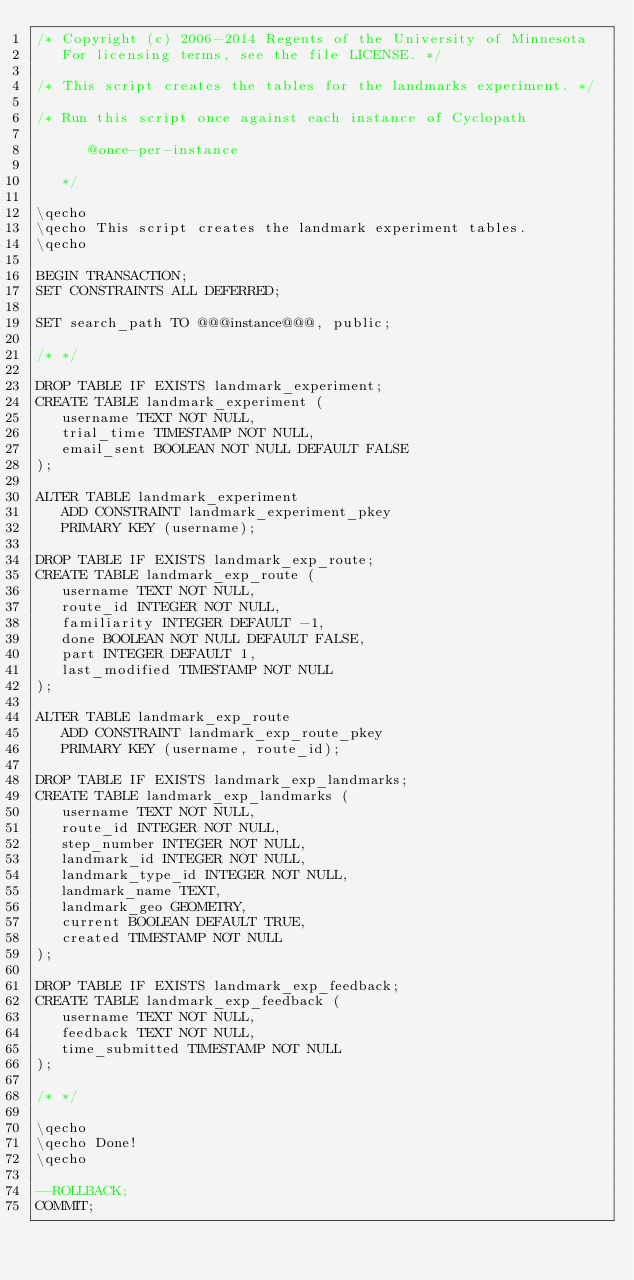<code> <loc_0><loc_0><loc_500><loc_500><_SQL_>/* Copyright (c) 2006-2014 Regents of the University of Minnesota
   For licensing terms, see the file LICENSE. */

/* This script creates the tables for the landmarks experiment. */

/* Run this script once against each instance of Cyclopath

      @once-per-instance

   */

\qecho
\qecho This script creates the landmark experiment tables.
\qecho

BEGIN TRANSACTION;
SET CONSTRAINTS ALL DEFERRED;

SET search_path TO @@@instance@@@, public;

/* */

DROP TABLE IF EXISTS landmark_experiment;
CREATE TABLE landmark_experiment (
   username TEXT NOT NULL,
   trial_time TIMESTAMP NOT NULL,
   email_sent BOOLEAN NOT NULL DEFAULT FALSE
);

ALTER TABLE landmark_experiment 
   ADD CONSTRAINT landmark_experiment_pkey 
   PRIMARY KEY (username);

DROP TABLE IF EXISTS landmark_exp_route;
CREATE TABLE landmark_exp_route (
   username TEXT NOT NULL,
   route_id INTEGER NOT NULL,
   familiarity INTEGER DEFAULT -1,
   done BOOLEAN NOT NULL DEFAULT FALSE,
   part INTEGER DEFAULT 1,
   last_modified TIMESTAMP NOT NULL
);

ALTER TABLE landmark_exp_route 
   ADD CONSTRAINT landmark_exp_route_pkey 
   PRIMARY KEY (username, route_id);

DROP TABLE IF EXISTS landmark_exp_landmarks;
CREATE TABLE landmark_exp_landmarks (
   username TEXT NOT NULL,
   route_id INTEGER NOT NULL,
   step_number INTEGER NOT NULL,
   landmark_id INTEGER NOT NULL,
   landmark_type_id INTEGER NOT NULL,
   landmark_name TEXT,
   landmark_geo GEOMETRY,
   current BOOLEAN DEFAULT TRUE,
   created TIMESTAMP NOT NULL
);

DROP TABLE IF EXISTS landmark_exp_feedback;
CREATE TABLE landmark_exp_feedback (
   username TEXT NOT NULL,
   feedback TEXT NOT NULL,
   time_submitted TIMESTAMP NOT NULL
);

/* */

\qecho
\qecho Done!
\qecho

--ROLLBACK;
COMMIT;

</code> 